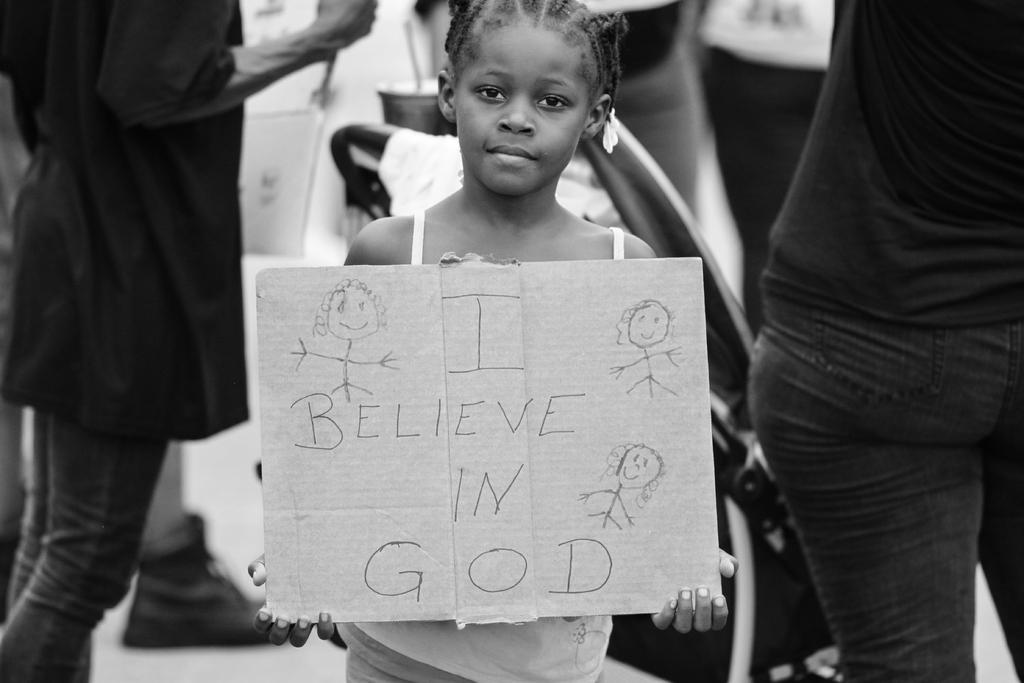Who is the main subject in the picture? There is a girl in the picture. What is the girl holding in the picture? The girl is holding a board with text. Are there any other people visible in the image? Yes, there are people standing behind the girl. What type of quill is the girl using to write on the board? There is no quill present in the image, and the girl is not writing on the board. 